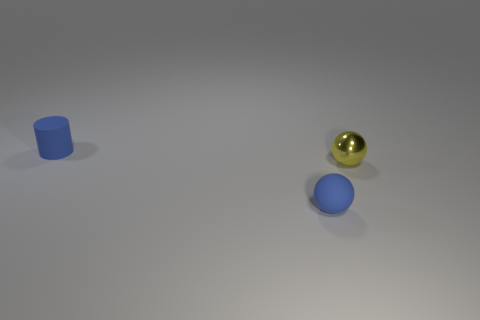Are there any tiny purple cubes that have the same material as the tiny cylinder?
Provide a short and direct response. No. What shape is the small object that is both on the left side of the small metallic ball and right of the tiny blue rubber cylinder?
Ensure brevity in your answer.  Sphere. How many tiny things are yellow rubber balls or rubber things?
Your answer should be compact. 2. What is the material of the blue sphere?
Make the answer very short. Rubber. What number of other things are there of the same shape as the yellow object?
Your answer should be very brief. 1. What size is the blue matte cylinder?
Make the answer very short. Small. How big is the object that is to the left of the tiny yellow ball and behind the blue matte sphere?
Your response must be concise. Small. The tiny blue object that is behind the yellow object has what shape?
Provide a succinct answer. Cylinder. Does the small cylinder have the same material as the tiny sphere that is left of the small yellow shiny sphere?
Make the answer very short. Yes. What is the material of the other object that is the same shape as the yellow object?
Offer a terse response. Rubber. 